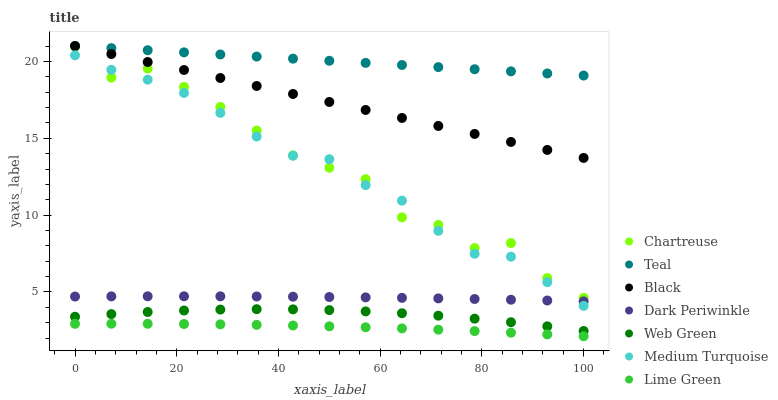Does Lime Green have the minimum area under the curve?
Answer yes or no. Yes. Does Teal have the maximum area under the curve?
Answer yes or no. Yes. Does Web Green have the minimum area under the curve?
Answer yes or no. No. Does Web Green have the maximum area under the curve?
Answer yes or no. No. Is Black the smoothest?
Answer yes or no. Yes. Is Chartreuse the roughest?
Answer yes or no. Yes. Is Web Green the smoothest?
Answer yes or no. No. Is Web Green the roughest?
Answer yes or no. No. Does Lime Green have the lowest value?
Answer yes or no. Yes. Does Web Green have the lowest value?
Answer yes or no. No. Does Teal have the highest value?
Answer yes or no. Yes. Does Web Green have the highest value?
Answer yes or no. No. Is Lime Green less than Medium Turquoise?
Answer yes or no. Yes. Is Chartreuse greater than Lime Green?
Answer yes or no. Yes. Does Dark Periwinkle intersect Medium Turquoise?
Answer yes or no. Yes. Is Dark Periwinkle less than Medium Turquoise?
Answer yes or no. No. Is Dark Periwinkle greater than Medium Turquoise?
Answer yes or no. No. Does Lime Green intersect Medium Turquoise?
Answer yes or no. No. 